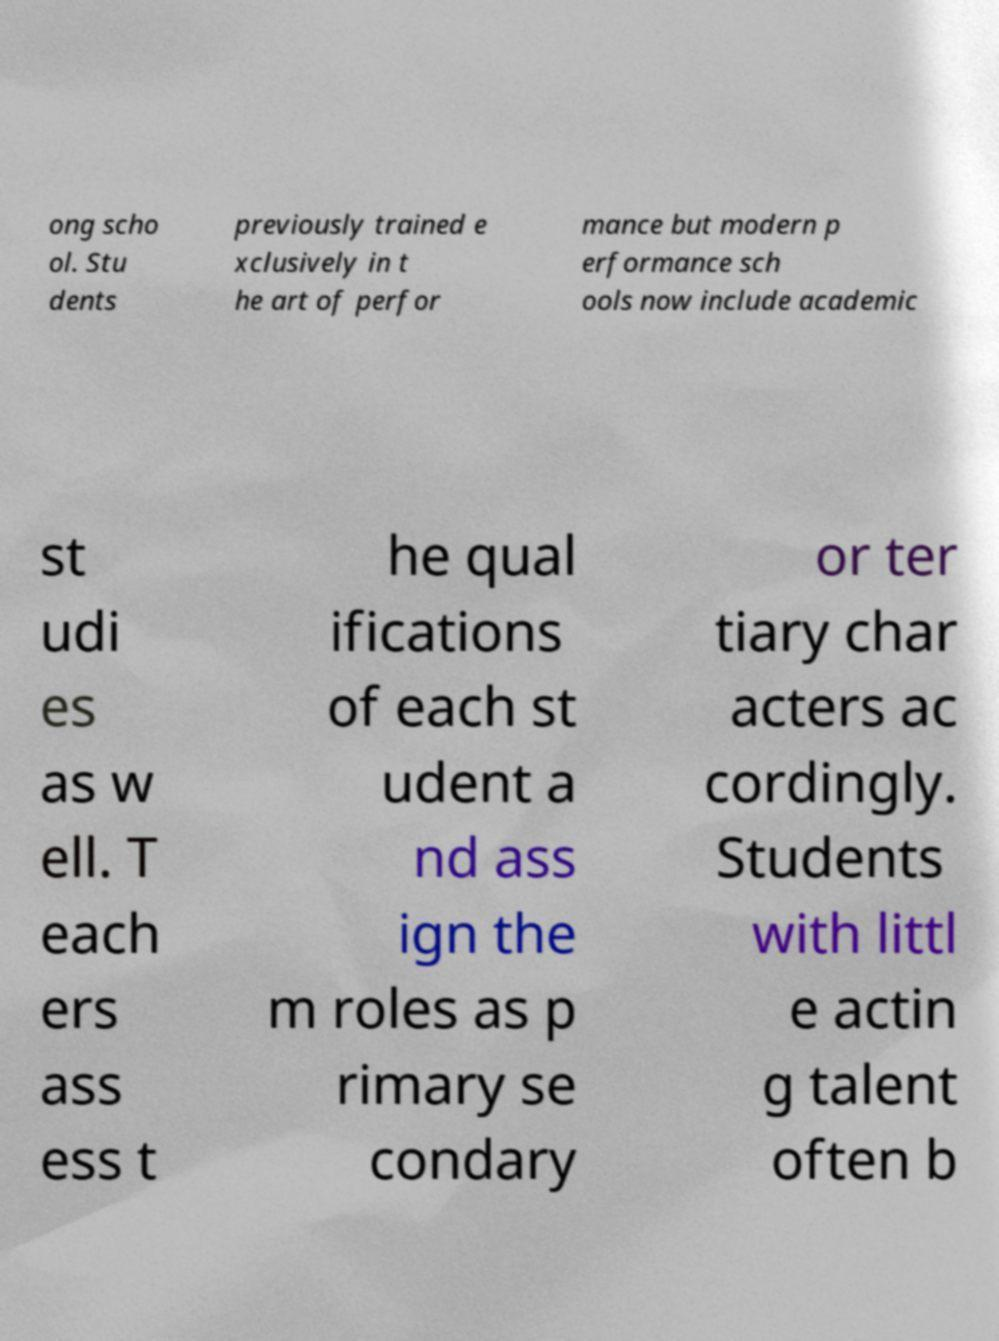What messages or text are displayed in this image? I need them in a readable, typed format. ong scho ol. Stu dents previously trained e xclusively in t he art of perfor mance but modern p erformance sch ools now include academic st udi es as w ell. T each ers ass ess t he qual ifications of each st udent a nd ass ign the m roles as p rimary se condary or ter tiary char acters ac cordingly. Students with littl e actin g talent often b 